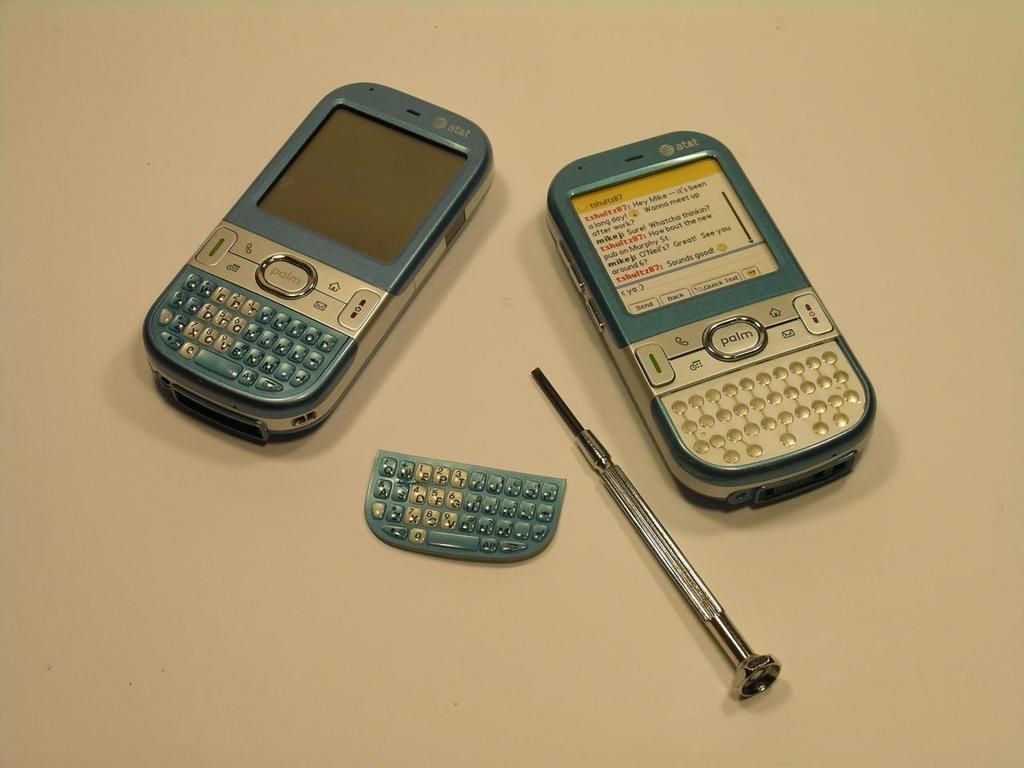How many mobiles can be seen in the image? There are two mobiles in the image. What tool is visible in the image? There is a screwdriver in the image. What type of device is present in the image? There is a keypad in the image. Can you describe the setting of the image? The image may have been taken in a room. How many brothers are present in the image? There is no mention of brothers in the image, as the facts provided do not include any information about people or family members. 